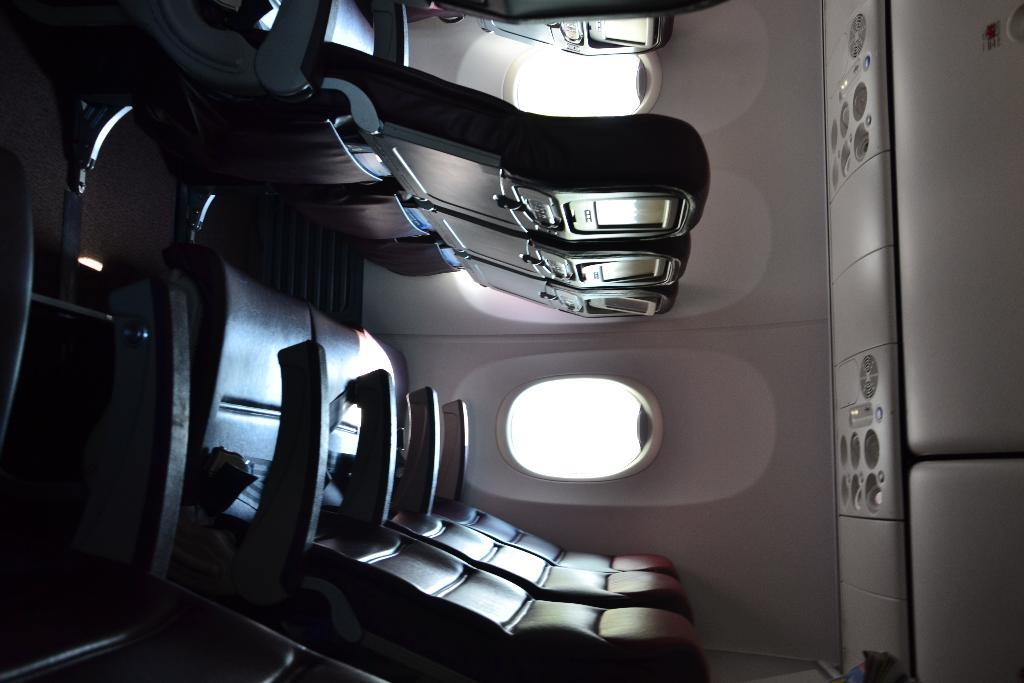What type of location is depicted in the image? The image is an inner view of an aeroplane. What can be seen in the middle of the image? There are chairs in the middle of the image. What is visible on the right side of the image? There are windows on the right side of the image. What type of club can be seen in the image? There is no club present in the image; it is an inner view of an aeroplane with chairs and windows. What activity is taking place in the image? The image does not depict any specific activity; it simply shows the interior of an aeroplane with chairs and windows. 